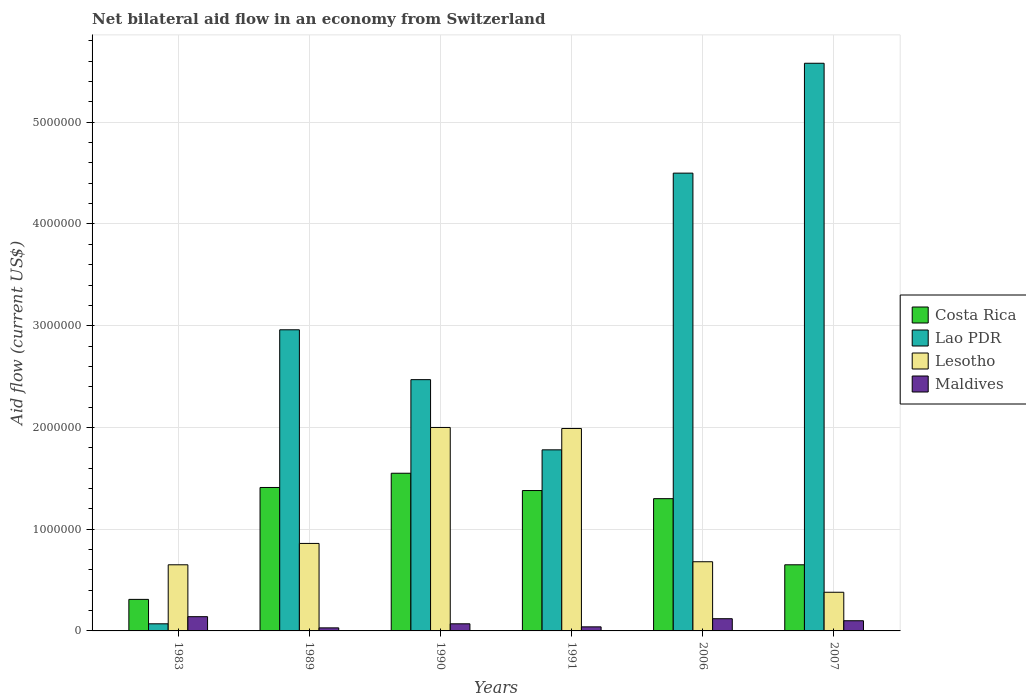How many groups of bars are there?
Provide a succinct answer. 6. How many bars are there on the 4th tick from the left?
Provide a short and direct response. 4. How many bars are there on the 6th tick from the right?
Your answer should be very brief. 4. What is the net bilateral aid flow in Costa Rica in 1991?
Offer a terse response. 1.38e+06. Across all years, what is the maximum net bilateral aid flow in Costa Rica?
Provide a succinct answer. 1.55e+06. Across all years, what is the minimum net bilateral aid flow in Maldives?
Make the answer very short. 3.00e+04. In which year was the net bilateral aid flow in Lesotho maximum?
Ensure brevity in your answer.  1990. What is the total net bilateral aid flow in Maldives in the graph?
Your answer should be very brief. 5.00e+05. What is the difference between the net bilateral aid flow in Maldives in 1990 and that in 2006?
Offer a terse response. -5.00e+04. What is the difference between the net bilateral aid flow in Lao PDR in 2007 and the net bilateral aid flow in Maldives in 1989?
Your answer should be compact. 5.55e+06. What is the average net bilateral aid flow in Maldives per year?
Your answer should be compact. 8.33e+04. In the year 1983, what is the difference between the net bilateral aid flow in Lesotho and net bilateral aid flow in Maldives?
Your answer should be very brief. 5.10e+05. In how many years, is the net bilateral aid flow in Lesotho greater than 2200000 US$?
Provide a succinct answer. 0. What is the ratio of the net bilateral aid flow in Lesotho in 1989 to that in 1990?
Give a very brief answer. 0.43. What is the difference between the highest and the lowest net bilateral aid flow in Lesotho?
Make the answer very short. 1.62e+06. In how many years, is the net bilateral aid flow in Costa Rica greater than the average net bilateral aid flow in Costa Rica taken over all years?
Provide a succinct answer. 4. What does the 3rd bar from the right in 2006 represents?
Provide a succinct answer. Lao PDR. Is it the case that in every year, the sum of the net bilateral aid flow in Maldives and net bilateral aid flow in Lesotho is greater than the net bilateral aid flow in Lao PDR?
Keep it short and to the point. No. Are all the bars in the graph horizontal?
Your answer should be very brief. No. How many years are there in the graph?
Offer a terse response. 6. Does the graph contain any zero values?
Make the answer very short. No. Where does the legend appear in the graph?
Provide a succinct answer. Center right. How many legend labels are there?
Ensure brevity in your answer.  4. How are the legend labels stacked?
Offer a terse response. Vertical. What is the title of the graph?
Keep it short and to the point. Net bilateral aid flow in an economy from Switzerland. Does "Grenada" appear as one of the legend labels in the graph?
Provide a short and direct response. No. What is the label or title of the X-axis?
Your response must be concise. Years. What is the label or title of the Y-axis?
Offer a very short reply. Aid flow (current US$). What is the Aid flow (current US$) in Lao PDR in 1983?
Ensure brevity in your answer.  7.00e+04. What is the Aid flow (current US$) of Lesotho in 1983?
Give a very brief answer. 6.50e+05. What is the Aid flow (current US$) of Maldives in 1983?
Offer a terse response. 1.40e+05. What is the Aid flow (current US$) of Costa Rica in 1989?
Your answer should be very brief. 1.41e+06. What is the Aid flow (current US$) in Lao PDR in 1989?
Offer a terse response. 2.96e+06. What is the Aid flow (current US$) of Lesotho in 1989?
Provide a succinct answer. 8.60e+05. What is the Aid flow (current US$) in Maldives in 1989?
Your answer should be compact. 3.00e+04. What is the Aid flow (current US$) in Costa Rica in 1990?
Give a very brief answer. 1.55e+06. What is the Aid flow (current US$) of Lao PDR in 1990?
Offer a very short reply. 2.47e+06. What is the Aid flow (current US$) of Costa Rica in 1991?
Ensure brevity in your answer.  1.38e+06. What is the Aid flow (current US$) of Lao PDR in 1991?
Ensure brevity in your answer.  1.78e+06. What is the Aid flow (current US$) of Lesotho in 1991?
Provide a short and direct response. 1.99e+06. What is the Aid flow (current US$) of Costa Rica in 2006?
Your response must be concise. 1.30e+06. What is the Aid flow (current US$) in Lao PDR in 2006?
Provide a short and direct response. 4.50e+06. What is the Aid flow (current US$) in Lesotho in 2006?
Ensure brevity in your answer.  6.80e+05. What is the Aid flow (current US$) in Costa Rica in 2007?
Keep it short and to the point. 6.50e+05. What is the Aid flow (current US$) in Lao PDR in 2007?
Your answer should be compact. 5.58e+06. What is the Aid flow (current US$) in Maldives in 2007?
Ensure brevity in your answer.  1.00e+05. Across all years, what is the maximum Aid flow (current US$) of Costa Rica?
Your answer should be very brief. 1.55e+06. Across all years, what is the maximum Aid flow (current US$) in Lao PDR?
Provide a succinct answer. 5.58e+06. Across all years, what is the maximum Aid flow (current US$) of Maldives?
Offer a terse response. 1.40e+05. Across all years, what is the minimum Aid flow (current US$) of Costa Rica?
Keep it short and to the point. 3.10e+05. Across all years, what is the minimum Aid flow (current US$) of Lao PDR?
Offer a terse response. 7.00e+04. What is the total Aid flow (current US$) of Costa Rica in the graph?
Your answer should be compact. 6.60e+06. What is the total Aid flow (current US$) of Lao PDR in the graph?
Provide a short and direct response. 1.74e+07. What is the total Aid flow (current US$) of Lesotho in the graph?
Offer a terse response. 6.56e+06. What is the difference between the Aid flow (current US$) in Costa Rica in 1983 and that in 1989?
Ensure brevity in your answer.  -1.10e+06. What is the difference between the Aid flow (current US$) in Lao PDR in 1983 and that in 1989?
Offer a very short reply. -2.89e+06. What is the difference between the Aid flow (current US$) in Costa Rica in 1983 and that in 1990?
Offer a terse response. -1.24e+06. What is the difference between the Aid flow (current US$) in Lao PDR in 1983 and that in 1990?
Give a very brief answer. -2.40e+06. What is the difference between the Aid flow (current US$) of Lesotho in 1983 and that in 1990?
Your response must be concise. -1.35e+06. What is the difference between the Aid flow (current US$) in Costa Rica in 1983 and that in 1991?
Give a very brief answer. -1.07e+06. What is the difference between the Aid flow (current US$) of Lao PDR in 1983 and that in 1991?
Your answer should be very brief. -1.71e+06. What is the difference between the Aid flow (current US$) in Lesotho in 1983 and that in 1991?
Give a very brief answer. -1.34e+06. What is the difference between the Aid flow (current US$) in Maldives in 1983 and that in 1991?
Provide a short and direct response. 1.00e+05. What is the difference between the Aid flow (current US$) in Costa Rica in 1983 and that in 2006?
Your answer should be very brief. -9.90e+05. What is the difference between the Aid flow (current US$) in Lao PDR in 1983 and that in 2006?
Make the answer very short. -4.43e+06. What is the difference between the Aid flow (current US$) of Maldives in 1983 and that in 2006?
Your answer should be compact. 2.00e+04. What is the difference between the Aid flow (current US$) in Lao PDR in 1983 and that in 2007?
Offer a very short reply. -5.51e+06. What is the difference between the Aid flow (current US$) of Lesotho in 1983 and that in 2007?
Keep it short and to the point. 2.70e+05. What is the difference between the Aid flow (current US$) of Costa Rica in 1989 and that in 1990?
Provide a succinct answer. -1.40e+05. What is the difference between the Aid flow (current US$) of Lesotho in 1989 and that in 1990?
Your response must be concise. -1.14e+06. What is the difference between the Aid flow (current US$) of Lao PDR in 1989 and that in 1991?
Offer a terse response. 1.18e+06. What is the difference between the Aid flow (current US$) in Lesotho in 1989 and that in 1991?
Your answer should be compact. -1.13e+06. What is the difference between the Aid flow (current US$) in Maldives in 1989 and that in 1991?
Your response must be concise. -10000. What is the difference between the Aid flow (current US$) of Costa Rica in 1989 and that in 2006?
Ensure brevity in your answer.  1.10e+05. What is the difference between the Aid flow (current US$) in Lao PDR in 1989 and that in 2006?
Offer a terse response. -1.54e+06. What is the difference between the Aid flow (current US$) of Lesotho in 1989 and that in 2006?
Provide a succinct answer. 1.80e+05. What is the difference between the Aid flow (current US$) of Costa Rica in 1989 and that in 2007?
Make the answer very short. 7.60e+05. What is the difference between the Aid flow (current US$) of Lao PDR in 1989 and that in 2007?
Give a very brief answer. -2.62e+06. What is the difference between the Aid flow (current US$) in Lesotho in 1989 and that in 2007?
Give a very brief answer. 4.80e+05. What is the difference between the Aid flow (current US$) of Maldives in 1989 and that in 2007?
Make the answer very short. -7.00e+04. What is the difference between the Aid flow (current US$) in Lao PDR in 1990 and that in 1991?
Make the answer very short. 6.90e+05. What is the difference between the Aid flow (current US$) in Lesotho in 1990 and that in 1991?
Offer a terse response. 10000. What is the difference between the Aid flow (current US$) in Maldives in 1990 and that in 1991?
Offer a very short reply. 3.00e+04. What is the difference between the Aid flow (current US$) of Costa Rica in 1990 and that in 2006?
Make the answer very short. 2.50e+05. What is the difference between the Aid flow (current US$) of Lao PDR in 1990 and that in 2006?
Make the answer very short. -2.03e+06. What is the difference between the Aid flow (current US$) of Lesotho in 1990 and that in 2006?
Provide a succinct answer. 1.32e+06. What is the difference between the Aid flow (current US$) in Costa Rica in 1990 and that in 2007?
Keep it short and to the point. 9.00e+05. What is the difference between the Aid flow (current US$) in Lao PDR in 1990 and that in 2007?
Offer a terse response. -3.11e+06. What is the difference between the Aid flow (current US$) of Lesotho in 1990 and that in 2007?
Offer a very short reply. 1.62e+06. What is the difference between the Aid flow (current US$) in Maldives in 1990 and that in 2007?
Give a very brief answer. -3.00e+04. What is the difference between the Aid flow (current US$) in Lao PDR in 1991 and that in 2006?
Provide a short and direct response. -2.72e+06. What is the difference between the Aid flow (current US$) of Lesotho in 1991 and that in 2006?
Make the answer very short. 1.31e+06. What is the difference between the Aid flow (current US$) of Maldives in 1991 and that in 2006?
Offer a very short reply. -8.00e+04. What is the difference between the Aid flow (current US$) of Costa Rica in 1991 and that in 2007?
Offer a very short reply. 7.30e+05. What is the difference between the Aid flow (current US$) of Lao PDR in 1991 and that in 2007?
Offer a terse response. -3.80e+06. What is the difference between the Aid flow (current US$) of Lesotho in 1991 and that in 2007?
Make the answer very short. 1.61e+06. What is the difference between the Aid flow (current US$) in Costa Rica in 2006 and that in 2007?
Keep it short and to the point. 6.50e+05. What is the difference between the Aid flow (current US$) in Lao PDR in 2006 and that in 2007?
Provide a succinct answer. -1.08e+06. What is the difference between the Aid flow (current US$) in Maldives in 2006 and that in 2007?
Provide a succinct answer. 2.00e+04. What is the difference between the Aid flow (current US$) in Costa Rica in 1983 and the Aid flow (current US$) in Lao PDR in 1989?
Keep it short and to the point. -2.65e+06. What is the difference between the Aid flow (current US$) of Costa Rica in 1983 and the Aid flow (current US$) of Lesotho in 1989?
Provide a short and direct response. -5.50e+05. What is the difference between the Aid flow (current US$) in Lao PDR in 1983 and the Aid flow (current US$) in Lesotho in 1989?
Keep it short and to the point. -7.90e+05. What is the difference between the Aid flow (current US$) of Lesotho in 1983 and the Aid flow (current US$) of Maldives in 1989?
Offer a very short reply. 6.20e+05. What is the difference between the Aid flow (current US$) of Costa Rica in 1983 and the Aid flow (current US$) of Lao PDR in 1990?
Make the answer very short. -2.16e+06. What is the difference between the Aid flow (current US$) in Costa Rica in 1983 and the Aid flow (current US$) in Lesotho in 1990?
Ensure brevity in your answer.  -1.69e+06. What is the difference between the Aid flow (current US$) of Costa Rica in 1983 and the Aid flow (current US$) of Maldives in 1990?
Provide a short and direct response. 2.40e+05. What is the difference between the Aid flow (current US$) of Lao PDR in 1983 and the Aid flow (current US$) of Lesotho in 1990?
Provide a short and direct response. -1.93e+06. What is the difference between the Aid flow (current US$) of Lesotho in 1983 and the Aid flow (current US$) of Maldives in 1990?
Offer a very short reply. 5.80e+05. What is the difference between the Aid flow (current US$) of Costa Rica in 1983 and the Aid flow (current US$) of Lao PDR in 1991?
Ensure brevity in your answer.  -1.47e+06. What is the difference between the Aid flow (current US$) in Costa Rica in 1983 and the Aid flow (current US$) in Lesotho in 1991?
Your answer should be very brief. -1.68e+06. What is the difference between the Aid flow (current US$) in Lao PDR in 1983 and the Aid flow (current US$) in Lesotho in 1991?
Your answer should be compact. -1.92e+06. What is the difference between the Aid flow (current US$) in Lao PDR in 1983 and the Aid flow (current US$) in Maldives in 1991?
Offer a very short reply. 3.00e+04. What is the difference between the Aid flow (current US$) of Costa Rica in 1983 and the Aid flow (current US$) of Lao PDR in 2006?
Offer a terse response. -4.19e+06. What is the difference between the Aid flow (current US$) of Costa Rica in 1983 and the Aid flow (current US$) of Lesotho in 2006?
Provide a succinct answer. -3.70e+05. What is the difference between the Aid flow (current US$) in Lao PDR in 1983 and the Aid flow (current US$) in Lesotho in 2006?
Provide a succinct answer. -6.10e+05. What is the difference between the Aid flow (current US$) of Lesotho in 1983 and the Aid flow (current US$) of Maldives in 2006?
Make the answer very short. 5.30e+05. What is the difference between the Aid flow (current US$) in Costa Rica in 1983 and the Aid flow (current US$) in Lao PDR in 2007?
Your answer should be very brief. -5.27e+06. What is the difference between the Aid flow (current US$) in Lao PDR in 1983 and the Aid flow (current US$) in Lesotho in 2007?
Provide a succinct answer. -3.10e+05. What is the difference between the Aid flow (current US$) of Lao PDR in 1983 and the Aid flow (current US$) of Maldives in 2007?
Provide a short and direct response. -3.00e+04. What is the difference between the Aid flow (current US$) in Costa Rica in 1989 and the Aid flow (current US$) in Lao PDR in 1990?
Provide a short and direct response. -1.06e+06. What is the difference between the Aid flow (current US$) of Costa Rica in 1989 and the Aid flow (current US$) of Lesotho in 1990?
Make the answer very short. -5.90e+05. What is the difference between the Aid flow (current US$) of Costa Rica in 1989 and the Aid flow (current US$) of Maldives in 1990?
Ensure brevity in your answer.  1.34e+06. What is the difference between the Aid flow (current US$) in Lao PDR in 1989 and the Aid flow (current US$) in Lesotho in 1990?
Your answer should be very brief. 9.60e+05. What is the difference between the Aid flow (current US$) of Lao PDR in 1989 and the Aid flow (current US$) of Maldives in 1990?
Provide a succinct answer. 2.89e+06. What is the difference between the Aid flow (current US$) in Lesotho in 1989 and the Aid flow (current US$) in Maldives in 1990?
Provide a short and direct response. 7.90e+05. What is the difference between the Aid flow (current US$) in Costa Rica in 1989 and the Aid flow (current US$) in Lao PDR in 1991?
Your response must be concise. -3.70e+05. What is the difference between the Aid flow (current US$) in Costa Rica in 1989 and the Aid flow (current US$) in Lesotho in 1991?
Keep it short and to the point. -5.80e+05. What is the difference between the Aid flow (current US$) of Costa Rica in 1989 and the Aid flow (current US$) of Maldives in 1991?
Offer a terse response. 1.37e+06. What is the difference between the Aid flow (current US$) of Lao PDR in 1989 and the Aid flow (current US$) of Lesotho in 1991?
Your response must be concise. 9.70e+05. What is the difference between the Aid flow (current US$) in Lao PDR in 1989 and the Aid flow (current US$) in Maldives in 1991?
Give a very brief answer. 2.92e+06. What is the difference between the Aid flow (current US$) in Lesotho in 1989 and the Aid flow (current US$) in Maldives in 1991?
Make the answer very short. 8.20e+05. What is the difference between the Aid flow (current US$) in Costa Rica in 1989 and the Aid flow (current US$) in Lao PDR in 2006?
Make the answer very short. -3.09e+06. What is the difference between the Aid flow (current US$) of Costa Rica in 1989 and the Aid flow (current US$) of Lesotho in 2006?
Provide a succinct answer. 7.30e+05. What is the difference between the Aid flow (current US$) of Costa Rica in 1989 and the Aid flow (current US$) of Maldives in 2006?
Provide a succinct answer. 1.29e+06. What is the difference between the Aid flow (current US$) of Lao PDR in 1989 and the Aid flow (current US$) of Lesotho in 2006?
Your response must be concise. 2.28e+06. What is the difference between the Aid flow (current US$) of Lao PDR in 1989 and the Aid flow (current US$) of Maldives in 2006?
Offer a very short reply. 2.84e+06. What is the difference between the Aid flow (current US$) in Lesotho in 1989 and the Aid flow (current US$) in Maldives in 2006?
Give a very brief answer. 7.40e+05. What is the difference between the Aid flow (current US$) in Costa Rica in 1989 and the Aid flow (current US$) in Lao PDR in 2007?
Offer a very short reply. -4.17e+06. What is the difference between the Aid flow (current US$) in Costa Rica in 1989 and the Aid flow (current US$) in Lesotho in 2007?
Provide a succinct answer. 1.03e+06. What is the difference between the Aid flow (current US$) of Costa Rica in 1989 and the Aid flow (current US$) of Maldives in 2007?
Your answer should be very brief. 1.31e+06. What is the difference between the Aid flow (current US$) of Lao PDR in 1989 and the Aid flow (current US$) of Lesotho in 2007?
Keep it short and to the point. 2.58e+06. What is the difference between the Aid flow (current US$) of Lao PDR in 1989 and the Aid flow (current US$) of Maldives in 2007?
Keep it short and to the point. 2.86e+06. What is the difference between the Aid flow (current US$) in Lesotho in 1989 and the Aid flow (current US$) in Maldives in 2007?
Your answer should be very brief. 7.60e+05. What is the difference between the Aid flow (current US$) of Costa Rica in 1990 and the Aid flow (current US$) of Lao PDR in 1991?
Offer a very short reply. -2.30e+05. What is the difference between the Aid flow (current US$) of Costa Rica in 1990 and the Aid flow (current US$) of Lesotho in 1991?
Provide a short and direct response. -4.40e+05. What is the difference between the Aid flow (current US$) of Costa Rica in 1990 and the Aid flow (current US$) of Maldives in 1991?
Provide a short and direct response. 1.51e+06. What is the difference between the Aid flow (current US$) in Lao PDR in 1990 and the Aid flow (current US$) in Maldives in 1991?
Your response must be concise. 2.43e+06. What is the difference between the Aid flow (current US$) of Lesotho in 1990 and the Aid flow (current US$) of Maldives in 1991?
Provide a short and direct response. 1.96e+06. What is the difference between the Aid flow (current US$) in Costa Rica in 1990 and the Aid flow (current US$) in Lao PDR in 2006?
Give a very brief answer. -2.95e+06. What is the difference between the Aid flow (current US$) in Costa Rica in 1990 and the Aid flow (current US$) in Lesotho in 2006?
Your answer should be compact. 8.70e+05. What is the difference between the Aid flow (current US$) in Costa Rica in 1990 and the Aid flow (current US$) in Maldives in 2006?
Your answer should be compact. 1.43e+06. What is the difference between the Aid flow (current US$) of Lao PDR in 1990 and the Aid flow (current US$) of Lesotho in 2006?
Provide a short and direct response. 1.79e+06. What is the difference between the Aid flow (current US$) in Lao PDR in 1990 and the Aid flow (current US$) in Maldives in 2006?
Give a very brief answer. 2.35e+06. What is the difference between the Aid flow (current US$) in Lesotho in 1990 and the Aid flow (current US$) in Maldives in 2006?
Provide a succinct answer. 1.88e+06. What is the difference between the Aid flow (current US$) in Costa Rica in 1990 and the Aid flow (current US$) in Lao PDR in 2007?
Keep it short and to the point. -4.03e+06. What is the difference between the Aid flow (current US$) in Costa Rica in 1990 and the Aid flow (current US$) in Lesotho in 2007?
Make the answer very short. 1.17e+06. What is the difference between the Aid flow (current US$) in Costa Rica in 1990 and the Aid flow (current US$) in Maldives in 2007?
Your answer should be compact. 1.45e+06. What is the difference between the Aid flow (current US$) of Lao PDR in 1990 and the Aid flow (current US$) of Lesotho in 2007?
Ensure brevity in your answer.  2.09e+06. What is the difference between the Aid flow (current US$) in Lao PDR in 1990 and the Aid flow (current US$) in Maldives in 2007?
Give a very brief answer. 2.37e+06. What is the difference between the Aid flow (current US$) of Lesotho in 1990 and the Aid flow (current US$) of Maldives in 2007?
Offer a very short reply. 1.90e+06. What is the difference between the Aid flow (current US$) of Costa Rica in 1991 and the Aid flow (current US$) of Lao PDR in 2006?
Provide a short and direct response. -3.12e+06. What is the difference between the Aid flow (current US$) of Costa Rica in 1991 and the Aid flow (current US$) of Maldives in 2006?
Give a very brief answer. 1.26e+06. What is the difference between the Aid flow (current US$) in Lao PDR in 1991 and the Aid flow (current US$) in Lesotho in 2006?
Your answer should be very brief. 1.10e+06. What is the difference between the Aid flow (current US$) of Lao PDR in 1991 and the Aid flow (current US$) of Maldives in 2006?
Give a very brief answer. 1.66e+06. What is the difference between the Aid flow (current US$) of Lesotho in 1991 and the Aid flow (current US$) of Maldives in 2006?
Your answer should be very brief. 1.87e+06. What is the difference between the Aid flow (current US$) of Costa Rica in 1991 and the Aid flow (current US$) of Lao PDR in 2007?
Your answer should be compact. -4.20e+06. What is the difference between the Aid flow (current US$) of Costa Rica in 1991 and the Aid flow (current US$) of Maldives in 2007?
Provide a short and direct response. 1.28e+06. What is the difference between the Aid flow (current US$) in Lao PDR in 1991 and the Aid flow (current US$) in Lesotho in 2007?
Keep it short and to the point. 1.40e+06. What is the difference between the Aid flow (current US$) of Lao PDR in 1991 and the Aid flow (current US$) of Maldives in 2007?
Make the answer very short. 1.68e+06. What is the difference between the Aid flow (current US$) in Lesotho in 1991 and the Aid flow (current US$) in Maldives in 2007?
Make the answer very short. 1.89e+06. What is the difference between the Aid flow (current US$) in Costa Rica in 2006 and the Aid flow (current US$) in Lao PDR in 2007?
Give a very brief answer. -4.28e+06. What is the difference between the Aid flow (current US$) in Costa Rica in 2006 and the Aid flow (current US$) in Lesotho in 2007?
Ensure brevity in your answer.  9.20e+05. What is the difference between the Aid flow (current US$) in Costa Rica in 2006 and the Aid flow (current US$) in Maldives in 2007?
Your response must be concise. 1.20e+06. What is the difference between the Aid flow (current US$) of Lao PDR in 2006 and the Aid flow (current US$) of Lesotho in 2007?
Ensure brevity in your answer.  4.12e+06. What is the difference between the Aid flow (current US$) in Lao PDR in 2006 and the Aid flow (current US$) in Maldives in 2007?
Keep it short and to the point. 4.40e+06. What is the difference between the Aid flow (current US$) in Lesotho in 2006 and the Aid flow (current US$) in Maldives in 2007?
Offer a very short reply. 5.80e+05. What is the average Aid flow (current US$) of Costa Rica per year?
Ensure brevity in your answer.  1.10e+06. What is the average Aid flow (current US$) in Lao PDR per year?
Your answer should be compact. 2.89e+06. What is the average Aid flow (current US$) in Lesotho per year?
Your response must be concise. 1.09e+06. What is the average Aid flow (current US$) of Maldives per year?
Your response must be concise. 8.33e+04. In the year 1983, what is the difference between the Aid flow (current US$) in Costa Rica and Aid flow (current US$) in Lao PDR?
Keep it short and to the point. 2.40e+05. In the year 1983, what is the difference between the Aid flow (current US$) in Lao PDR and Aid flow (current US$) in Lesotho?
Your answer should be compact. -5.80e+05. In the year 1983, what is the difference between the Aid flow (current US$) in Lao PDR and Aid flow (current US$) in Maldives?
Keep it short and to the point. -7.00e+04. In the year 1983, what is the difference between the Aid flow (current US$) of Lesotho and Aid flow (current US$) of Maldives?
Your answer should be very brief. 5.10e+05. In the year 1989, what is the difference between the Aid flow (current US$) of Costa Rica and Aid flow (current US$) of Lao PDR?
Your answer should be compact. -1.55e+06. In the year 1989, what is the difference between the Aid flow (current US$) of Costa Rica and Aid flow (current US$) of Lesotho?
Ensure brevity in your answer.  5.50e+05. In the year 1989, what is the difference between the Aid flow (current US$) of Costa Rica and Aid flow (current US$) of Maldives?
Offer a very short reply. 1.38e+06. In the year 1989, what is the difference between the Aid flow (current US$) in Lao PDR and Aid flow (current US$) in Lesotho?
Offer a terse response. 2.10e+06. In the year 1989, what is the difference between the Aid flow (current US$) in Lao PDR and Aid flow (current US$) in Maldives?
Your answer should be very brief. 2.93e+06. In the year 1989, what is the difference between the Aid flow (current US$) of Lesotho and Aid flow (current US$) of Maldives?
Provide a short and direct response. 8.30e+05. In the year 1990, what is the difference between the Aid flow (current US$) in Costa Rica and Aid flow (current US$) in Lao PDR?
Your response must be concise. -9.20e+05. In the year 1990, what is the difference between the Aid flow (current US$) in Costa Rica and Aid flow (current US$) in Lesotho?
Your answer should be compact. -4.50e+05. In the year 1990, what is the difference between the Aid flow (current US$) in Costa Rica and Aid flow (current US$) in Maldives?
Offer a very short reply. 1.48e+06. In the year 1990, what is the difference between the Aid flow (current US$) in Lao PDR and Aid flow (current US$) in Lesotho?
Make the answer very short. 4.70e+05. In the year 1990, what is the difference between the Aid flow (current US$) of Lao PDR and Aid flow (current US$) of Maldives?
Keep it short and to the point. 2.40e+06. In the year 1990, what is the difference between the Aid flow (current US$) of Lesotho and Aid flow (current US$) of Maldives?
Give a very brief answer. 1.93e+06. In the year 1991, what is the difference between the Aid flow (current US$) in Costa Rica and Aid flow (current US$) in Lao PDR?
Offer a terse response. -4.00e+05. In the year 1991, what is the difference between the Aid flow (current US$) in Costa Rica and Aid flow (current US$) in Lesotho?
Keep it short and to the point. -6.10e+05. In the year 1991, what is the difference between the Aid flow (current US$) in Costa Rica and Aid flow (current US$) in Maldives?
Provide a short and direct response. 1.34e+06. In the year 1991, what is the difference between the Aid flow (current US$) in Lao PDR and Aid flow (current US$) in Maldives?
Give a very brief answer. 1.74e+06. In the year 1991, what is the difference between the Aid flow (current US$) in Lesotho and Aid flow (current US$) in Maldives?
Your answer should be compact. 1.95e+06. In the year 2006, what is the difference between the Aid flow (current US$) of Costa Rica and Aid flow (current US$) of Lao PDR?
Your answer should be very brief. -3.20e+06. In the year 2006, what is the difference between the Aid flow (current US$) in Costa Rica and Aid flow (current US$) in Lesotho?
Give a very brief answer. 6.20e+05. In the year 2006, what is the difference between the Aid flow (current US$) in Costa Rica and Aid flow (current US$) in Maldives?
Ensure brevity in your answer.  1.18e+06. In the year 2006, what is the difference between the Aid flow (current US$) of Lao PDR and Aid flow (current US$) of Lesotho?
Ensure brevity in your answer.  3.82e+06. In the year 2006, what is the difference between the Aid flow (current US$) in Lao PDR and Aid flow (current US$) in Maldives?
Your answer should be compact. 4.38e+06. In the year 2006, what is the difference between the Aid flow (current US$) in Lesotho and Aid flow (current US$) in Maldives?
Offer a very short reply. 5.60e+05. In the year 2007, what is the difference between the Aid flow (current US$) in Costa Rica and Aid flow (current US$) in Lao PDR?
Give a very brief answer. -4.93e+06. In the year 2007, what is the difference between the Aid flow (current US$) in Costa Rica and Aid flow (current US$) in Lesotho?
Provide a succinct answer. 2.70e+05. In the year 2007, what is the difference between the Aid flow (current US$) of Lao PDR and Aid flow (current US$) of Lesotho?
Offer a terse response. 5.20e+06. In the year 2007, what is the difference between the Aid flow (current US$) of Lao PDR and Aid flow (current US$) of Maldives?
Your answer should be compact. 5.48e+06. What is the ratio of the Aid flow (current US$) in Costa Rica in 1983 to that in 1989?
Offer a very short reply. 0.22. What is the ratio of the Aid flow (current US$) in Lao PDR in 1983 to that in 1989?
Give a very brief answer. 0.02. What is the ratio of the Aid flow (current US$) in Lesotho in 1983 to that in 1989?
Keep it short and to the point. 0.76. What is the ratio of the Aid flow (current US$) of Maldives in 1983 to that in 1989?
Make the answer very short. 4.67. What is the ratio of the Aid flow (current US$) in Costa Rica in 1983 to that in 1990?
Give a very brief answer. 0.2. What is the ratio of the Aid flow (current US$) of Lao PDR in 1983 to that in 1990?
Offer a very short reply. 0.03. What is the ratio of the Aid flow (current US$) in Lesotho in 1983 to that in 1990?
Your response must be concise. 0.33. What is the ratio of the Aid flow (current US$) in Maldives in 1983 to that in 1990?
Give a very brief answer. 2. What is the ratio of the Aid flow (current US$) in Costa Rica in 1983 to that in 1991?
Keep it short and to the point. 0.22. What is the ratio of the Aid flow (current US$) of Lao PDR in 1983 to that in 1991?
Offer a terse response. 0.04. What is the ratio of the Aid flow (current US$) of Lesotho in 1983 to that in 1991?
Give a very brief answer. 0.33. What is the ratio of the Aid flow (current US$) in Maldives in 1983 to that in 1991?
Offer a terse response. 3.5. What is the ratio of the Aid flow (current US$) of Costa Rica in 1983 to that in 2006?
Your answer should be compact. 0.24. What is the ratio of the Aid flow (current US$) in Lao PDR in 1983 to that in 2006?
Offer a very short reply. 0.02. What is the ratio of the Aid flow (current US$) in Lesotho in 1983 to that in 2006?
Offer a very short reply. 0.96. What is the ratio of the Aid flow (current US$) of Maldives in 1983 to that in 2006?
Keep it short and to the point. 1.17. What is the ratio of the Aid flow (current US$) of Costa Rica in 1983 to that in 2007?
Provide a short and direct response. 0.48. What is the ratio of the Aid flow (current US$) of Lao PDR in 1983 to that in 2007?
Make the answer very short. 0.01. What is the ratio of the Aid flow (current US$) of Lesotho in 1983 to that in 2007?
Your answer should be compact. 1.71. What is the ratio of the Aid flow (current US$) of Costa Rica in 1989 to that in 1990?
Give a very brief answer. 0.91. What is the ratio of the Aid flow (current US$) of Lao PDR in 1989 to that in 1990?
Ensure brevity in your answer.  1.2. What is the ratio of the Aid flow (current US$) in Lesotho in 1989 to that in 1990?
Your response must be concise. 0.43. What is the ratio of the Aid flow (current US$) of Maldives in 1989 to that in 1990?
Your response must be concise. 0.43. What is the ratio of the Aid flow (current US$) of Costa Rica in 1989 to that in 1991?
Keep it short and to the point. 1.02. What is the ratio of the Aid flow (current US$) in Lao PDR in 1989 to that in 1991?
Provide a short and direct response. 1.66. What is the ratio of the Aid flow (current US$) in Lesotho in 1989 to that in 1991?
Offer a terse response. 0.43. What is the ratio of the Aid flow (current US$) of Maldives in 1989 to that in 1991?
Ensure brevity in your answer.  0.75. What is the ratio of the Aid flow (current US$) in Costa Rica in 1989 to that in 2006?
Your response must be concise. 1.08. What is the ratio of the Aid flow (current US$) of Lao PDR in 1989 to that in 2006?
Ensure brevity in your answer.  0.66. What is the ratio of the Aid flow (current US$) of Lesotho in 1989 to that in 2006?
Ensure brevity in your answer.  1.26. What is the ratio of the Aid flow (current US$) in Maldives in 1989 to that in 2006?
Offer a terse response. 0.25. What is the ratio of the Aid flow (current US$) in Costa Rica in 1989 to that in 2007?
Keep it short and to the point. 2.17. What is the ratio of the Aid flow (current US$) of Lao PDR in 1989 to that in 2007?
Your answer should be very brief. 0.53. What is the ratio of the Aid flow (current US$) in Lesotho in 1989 to that in 2007?
Your response must be concise. 2.26. What is the ratio of the Aid flow (current US$) in Maldives in 1989 to that in 2007?
Keep it short and to the point. 0.3. What is the ratio of the Aid flow (current US$) of Costa Rica in 1990 to that in 1991?
Keep it short and to the point. 1.12. What is the ratio of the Aid flow (current US$) in Lao PDR in 1990 to that in 1991?
Offer a very short reply. 1.39. What is the ratio of the Aid flow (current US$) in Lesotho in 1990 to that in 1991?
Give a very brief answer. 1. What is the ratio of the Aid flow (current US$) in Costa Rica in 1990 to that in 2006?
Offer a very short reply. 1.19. What is the ratio of the Aid flow (current US$) in Lao PDR in 1990 to that in 2006?
Give a very brief answer. 0.55. What is the ratio of the Aid flow (current US$) in Lesotho in 1990 to that in 2006?
Offer a terse response. 2.94. What is the ratio of the Aid flow (current US$) of Maldives in 1990 to that in 2006?
Make the answer very short. 0.58. What is the ratio of the Aid flow (current US$) in Costa Rica in 1990 to that in 2007?
Give a very brief answer. 2.38. What is the ratio of the Aid flow (current US$) of Lao PDR in 1990 to that in 2007?
Offer a terse response. 0.44. What is the ratio of the Aid flow (current US$) in Lesotho in 1990 to that in 2007?
Offer a very short reply. 5.26. What is the ratio of the Aid flow (current US$) in Costa Rica in 1991 to that in 2006?
Ensure brevity in your answer.  1.06. What is the ratio of the Aid flow (current US$) in Lao PDR in 1991 to that in 2006?
Offer a very short reply. 0.4. What is the ratio of the Aid flow (current US$) in Lesotho in 1991 to that in 2006?
Provide a succinct answer. 2.93. What is the ratio of the Aid flow (current US$) of Maldives in 1991 to that in 2006?
Provide a short and direct response. 0.33. What is the ratio of the Aid flow (current US$) in Costa Rica in 1991 to that in 2007?
Give a very brief answer. 2.12. What is the ratio of the Aid flow (current US$) of Lao PDR in 1991 to that in 2007?
Offer a terse response. 0.32. What is the ratio of the Aid flow (current US$) of Lesotho in 1991 to that in 2007?
Give a very brief answer. 5.24. What is the ratio of the Aid flow (current US$) of Maldives in 1991 to that in 2007?
Offer a very short reply. 0.4. What is the ratio of the Aid flow (current US$) of Lao PDR in 2006 to that in 2007?
Make the answer very short. 0.81. What is the ratio of the Aid flow (current US$) in Lesotho in 2006 to that in 2007?
Offer a very short reply. 1.79. What is the ratio of the Aid flow (current US$) in Maldives in 2006 to that in 2007?
Offer a terse response. 1.2. What is the difference between the highest and the second highest Aid flow (current US$) of Lao PDR?
Provide a short and direct response. 1.08e+06. What is the difference between the highest and the lowest Aid flow (current US$) in Costa Rica?
Provide a short and direct response. 1.24e+06. What is the difference between the highest and the lowest Aid flow (current US$) of Lao PDR?
Provide a succinct answer. 5.51e+06. What is the difference between the highest and the lowest Aid flow (current US$) of Lesotho?
Your answer should be compact. 1.62e+06. 